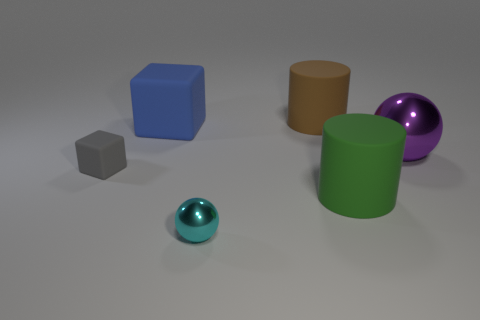Is the material of the large cube the same as the purple thing?
Provide a short and direct response. No. There is a matte cylinder behind the purple metallic sphere; is there a shiny object that is to the right of it?
Provide a short and direct response. Yes. What number of rubber things are both left of the tiny sphere and behind the purple ball?
Your answer should be very brief. 1. There is a matte thing that is to the left of the large blue matte thing; what is its shape?
Provide a short and direct response. Cube. How many gray things are the same size as the green matte thing?
Make the answer very short. 0. What is the material of the thing that is left of the brown cylinder and on the right side of the blue cube?
Provide a succinct answer. Metal. Are there more large purple balls than rubber cylinders?
Ensure brevity in your answer.  No. What is the color of the big cylinder that is right of the big brown thing behind the metallic sphere that is on the right side of the tiny metallic object?
Your answer should be very brief. Green. Does the big thing that is to the left of the tiny ball have the same material as the tiny cyan ball?
Provide a succinct answer. No. Are there any tiny gray rubber objects?
Provide a short and direct response. Yes. 